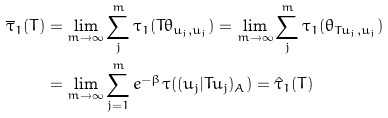<formula> <loc_0><loc_0><loc_500><loc_500>\overline { \tau } _ { 1 } ( T ) & = \lim _ { m \to \infty } \sum _ { j } ^ { m } \tau _ { 1 } ( T \theta _ { u _ { j } , u _ { j } } ) = \lim _ { m \to \infty } \sum _ { j } ^ { m } \tau _ { 1 } ( \theta _ { T u _ { j } , u _ { j } } ) \\ & = \lim _ { m \to \infty } \sum _ { j = 1 } ^ { m } e ^ { - \beta } \tau ( ( u _ { j } | T u _ { j } ) _ { A } ) = \hat { \tau } _ { 1 } ( T )</formula> 